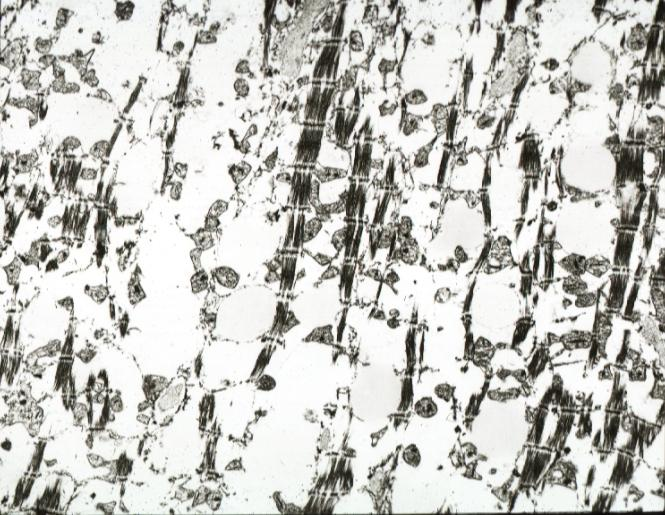s chronic ischemia present?
Answer the question using a single word or phrase. Yes 